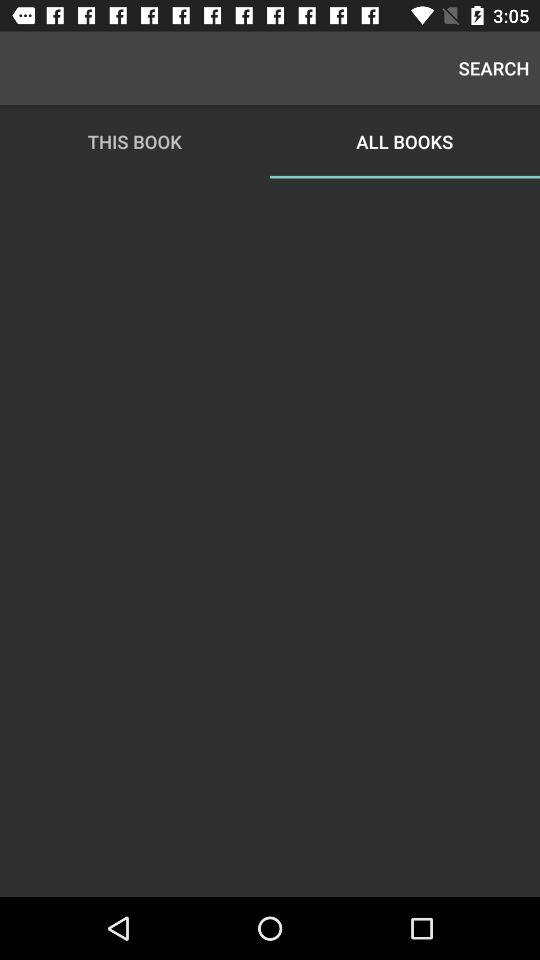Which option has been selected? The option that has been selected is "ALL BOOKS". 